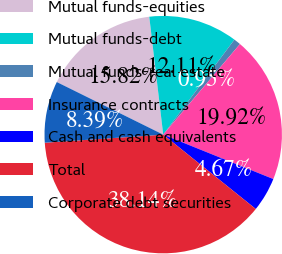Convert chart. <chart><loc_0><loc_0><loc_500><loc_500><pie_chart><fcel>Mutual funds-equities<fcel>Mutual funds-debt<fcel>Mutual funds-real estate<fcel>Insurance contracts<fcel>Cash and cash equivalents<fcel>Total<fcel>Corporate debt securities<nl><fcel>15.82%<fcel>12.11%<fcel>0.95%<fcel>19.92%<fcel>4.67%<fcel>38.14%<fcel>8.39%<nl></chart> 